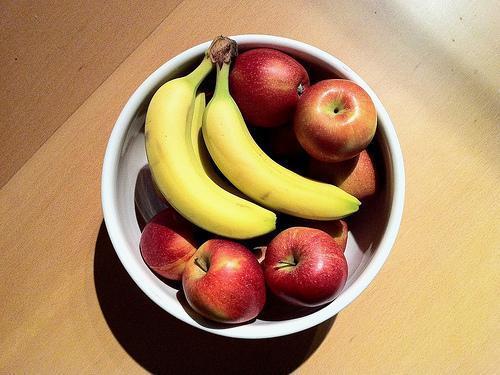How many bananas are there?
Give a very brief answer. 3. 